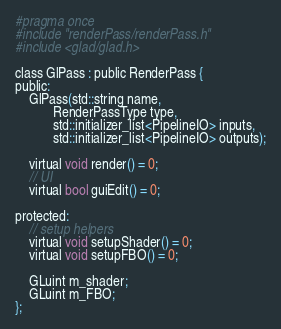Convert code to text. <code><loc_0><loc_0><loc_500><loc_500><_C_>#pragma once
#include "renderPass/renderPass.h"
#include <glad/glad.h>

class GlPass : public RenderPass {
public:
	GlPass(std::string name,
		   RenderPassType type,
		   std::initializer_list<PipelineIO> inputs,
		   std::initializer_list<PipelineIO> outputs);

	virtual void render() = 0;
	// UI
	virtual bool guiEdit() = 0;

protected:
	// setup helpers
	virtual void setupShader() = 0;
	virtual void setupFBO() = 0;

	GLuint m_shader;
	GLuint m_FBO;
};</code> 